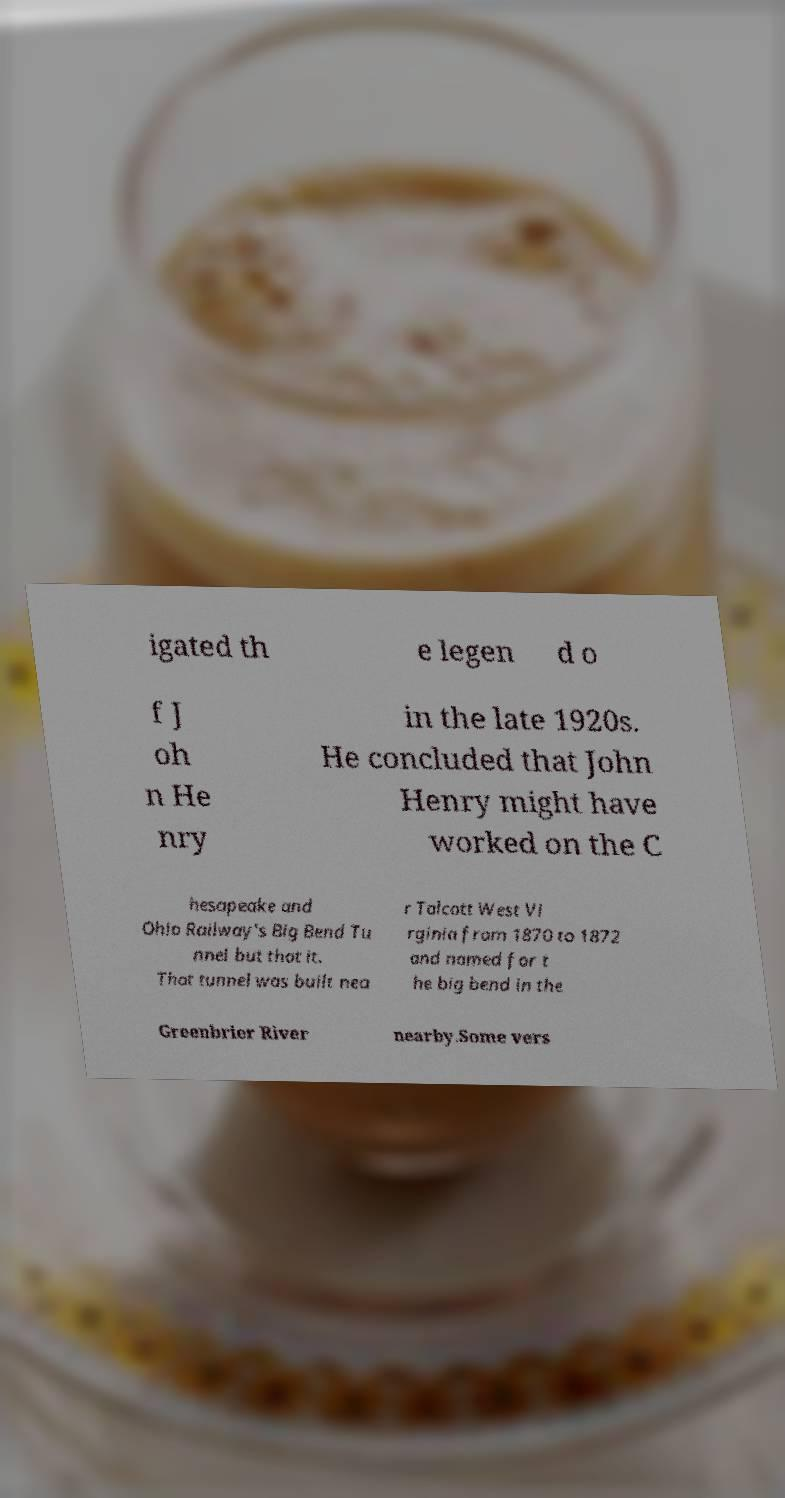Please read and relay the text visible in this image. What does it say? igated th e legen d o f J oh n He nry in the late 1920s. He concluded that John Henry might have worked on the C hesapeake and Ohio Railway's Big Bend Tu nnel but that it. That tunnel was built nea r Talcott West Vi rginia from 1870 to 1872 and named for t he big bend in the Greenbrier River nearby.Some vers 